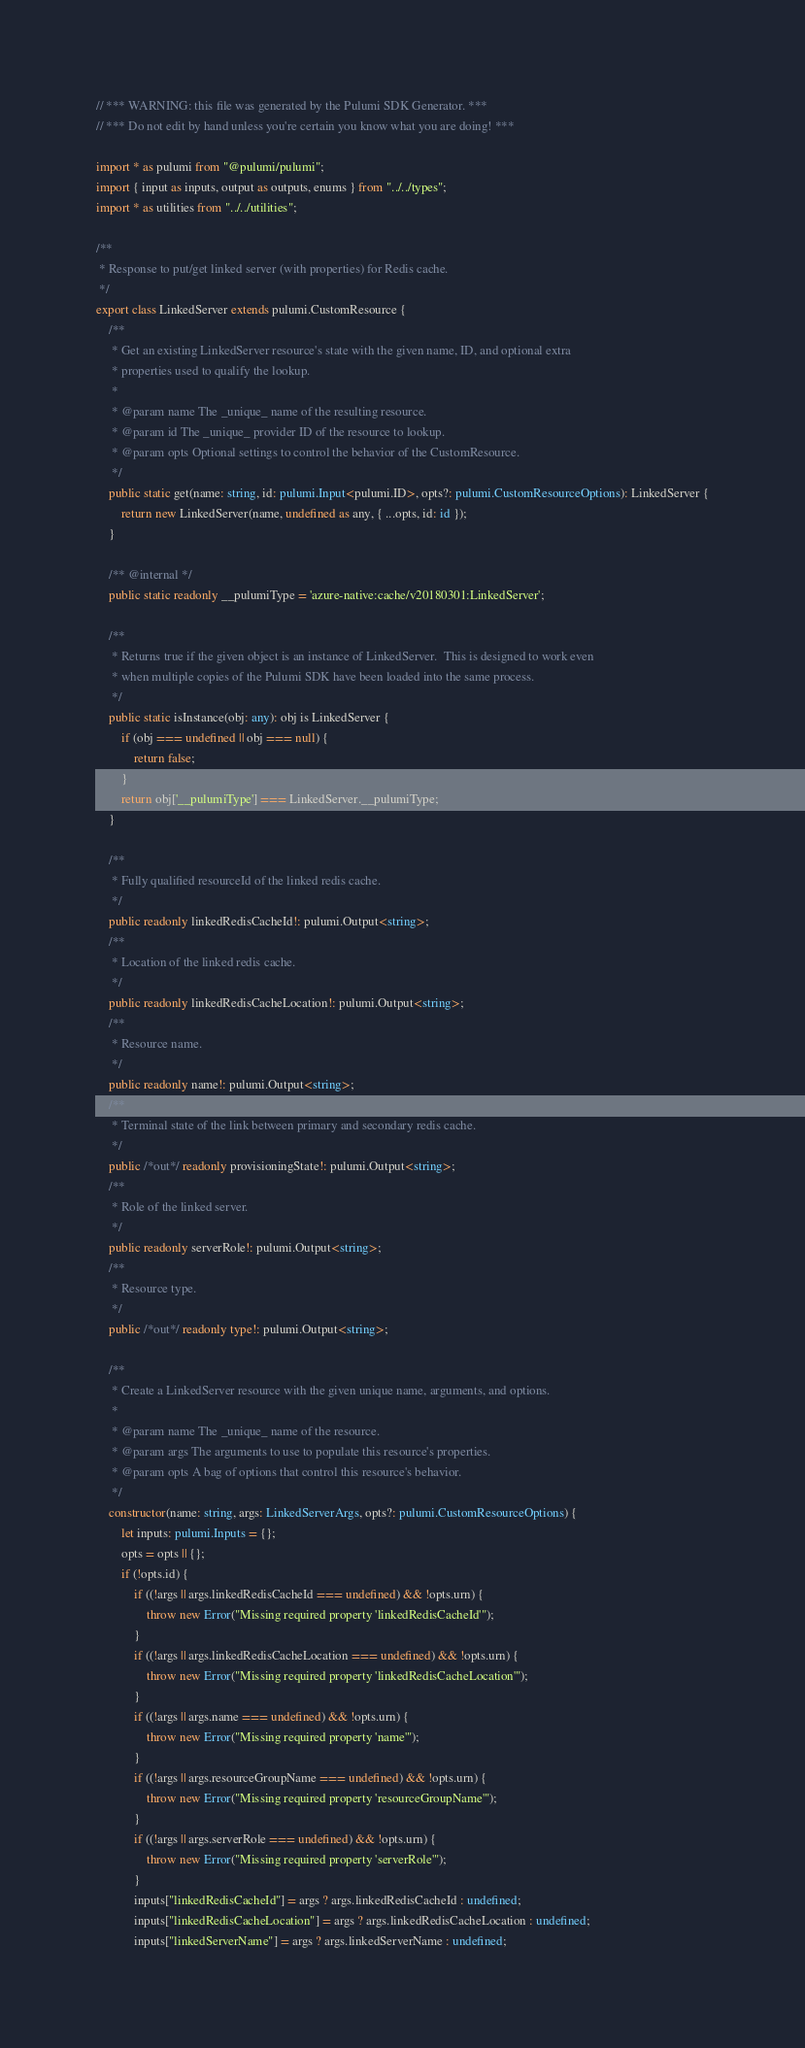<code> <loc_0><loc_0><loc_500><loc_500><_TypeScript_>// *** WARNING: this file was generated by the Pulumi SDK Generator. ***
// *** Do not edit by hand unless you're certain you know what you are doing! ***

import * as pulumi from "@pulumi/pulumi";
import { input as inputs, output as outputs, enums } from "../../types";
import * as utilities from "../../utilities";

/**
 * Response to put/get linked server (with properties) for Redis cache.
 */
export class LinkedServer extends pulumi.CustomResource {
    /**
     * Get an existing LinkedServer resource's state with the given name, ID, and optional extra
     * properties used to qualify the lookup.
     *
     * @param name The _unique_ name of the resulting resource.
     * @param id The _unique_ provider ID of the resource to lookup.
     * @param opts Optional settings to control the behavior of the CustomResource.
     */
    public static get(name: string, id: pulumi.Input<pulumi.ID>, opts?: pulumi.CustomResourceOptions): LinkedServer {
        return new LinkedServer(name, undefined as any, { ...opts, id: id });
    }

    /** @internal */
    public static readonly __pulumiType = 'azure-native:cache/v20180301:LinkedServer';

    /**
     * Returns true if the given object is an instance of LinkedServer.  This is designed to work even
     * when multiple copies of the Pulumi SDK have been loaded into the same process.
     */
    public static isInstance(obj: any): obj is LinkedServer {
        if (obj === undefined || obj === null) {
            return false;
        }
        return obj['__pulumiType'] === LinkedServer.__pulumiType;
    }

    /**
     * Fully qualified resourceId of the linked redis cache.
     */
    public readonly linkedRedisCacheId!: pulumi.Output<string>;
    /**
     * Location of the linked redis cache.
     */
    public readonly linkedRedisCacheLocation!: pulumi.Output<string>;
    /**
     * Resource name.
     */
    public readonly name!: pulumi.Output<string>;
    /**
     * Terminal state of the link between primary and secondary redis cache.
     */
    public /*out*/ readonly provisioningState!: pulumi.Output<string>;
    /**
     * Role of the linked server.
     */
    public readonly serverRole!: pulumi.Output<string>;
    /**
     * Resource type.
     */
    public /*out*/ readonly type!: pulumi.Output<string>;

    /**
     * Create a LinkedServer resource with the given unique name, arguments, and options.
     *
     * @param name The _unique_ name of the resource.
     * @param args The arguments to use to populate this resource's properties.
     * @param opts A bag of options that control this resource's behavior.
     */
    constructor(name: string, args: LinkedServerArgs, opts?: pulumi.CustomResourceOptions) {
        let inputs: pulumi.Inputs = {};
        opts = opts || {};
        if (!opts.id) {
            if ((!args || args.linkedRedisCacheId === undefined) && !opts.urn) {
                throw new Error("Missing required property 'linkedRedisCacheId'");
            }
            if ((!args || args.linkedRedisCacheLocation === undefined) && !opts.urn) {
                throw new Error("Missing required property 'linkedRedisCacheLocation'");
            }
            if ((!args || args.name === undefined) && !opts.urn) {
                throw new Error("Missing required property 'name'");
            }
            if ((!args || args.resourceGroupName === undefined) && !opts.urn) {
                throw new Error("Missing required property 'resourceGroupName'");
            }
            if ((!args || args.serverRole === undefined) && !opts.urn) {
                throw new Error("Missing required property 'serverRole'");
            }
            inputs["linkedRedisCacheId"] = args ? args.linkedRedisCacheId : undefined;
            inputs["linkedRedisCacheLocation"] = args ? args.linkedRedisCacheLocation : undefined;
            inputs["linkedServerName"] = args ? args.linkedServerName : undefined;</code> 